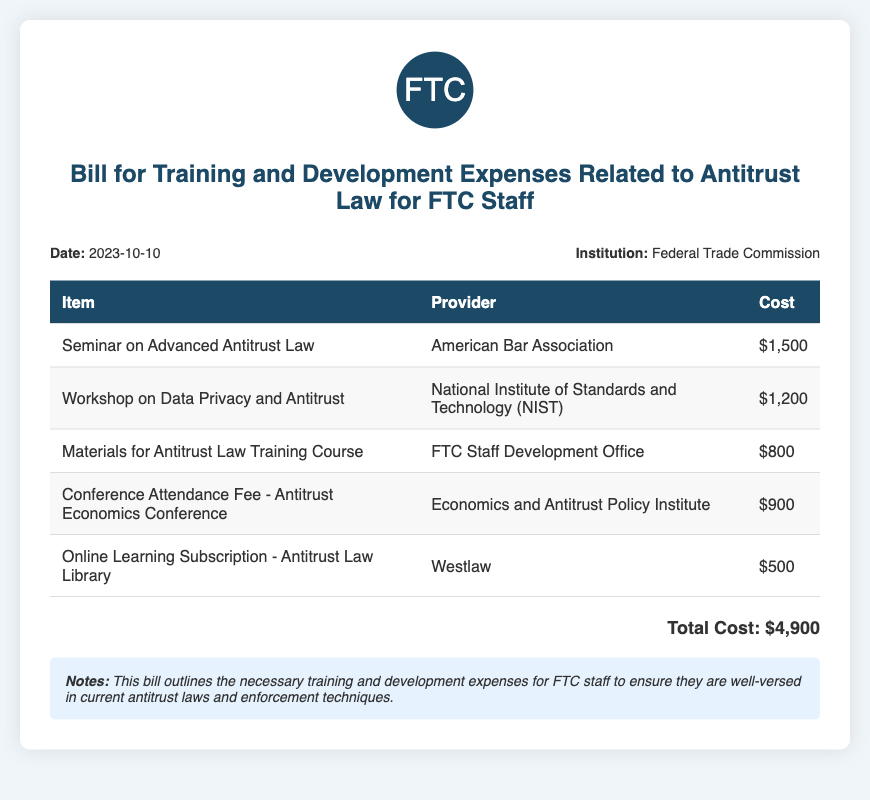What is the date of the bill? The date of the bill is specified in the document.
Answer: 2023-10-10 Who is the provider for the seminar on Advanced Antitrust Law? The provider for this seminar is listed in the document.
Answer: American Bar Association What is the total cost of the training and development expenses? The total cost is calculated based on the listed expenses in the document.
Answer: $4,900 How much does the Conference Attendance Fee cost? The cost for the Conference Attendance Fee is indicated in the expenses table.
Answer: $900 What is the cost of the Online Learning Subscription? The cost for the Online Learning Subscription is detailed in the table.
Answer: $500 What type of document is this? The document serves a specific purpose and outlines expenses.
Answer: Bill Which office is responsible for providing materials for the antitrust law training course? The responsible office is listed next to the corresponding item in the document.
Answer: FTC Staff Development Office What is the purpose of the bill as outlined in the notes? The notes provide insight into the purpose of the bill.
Answer: To ensure staff are well-versed in antitrust laws How many items are listed in the expenses table? The total number of items can be counted from the table section of the document.
Answer: 5 